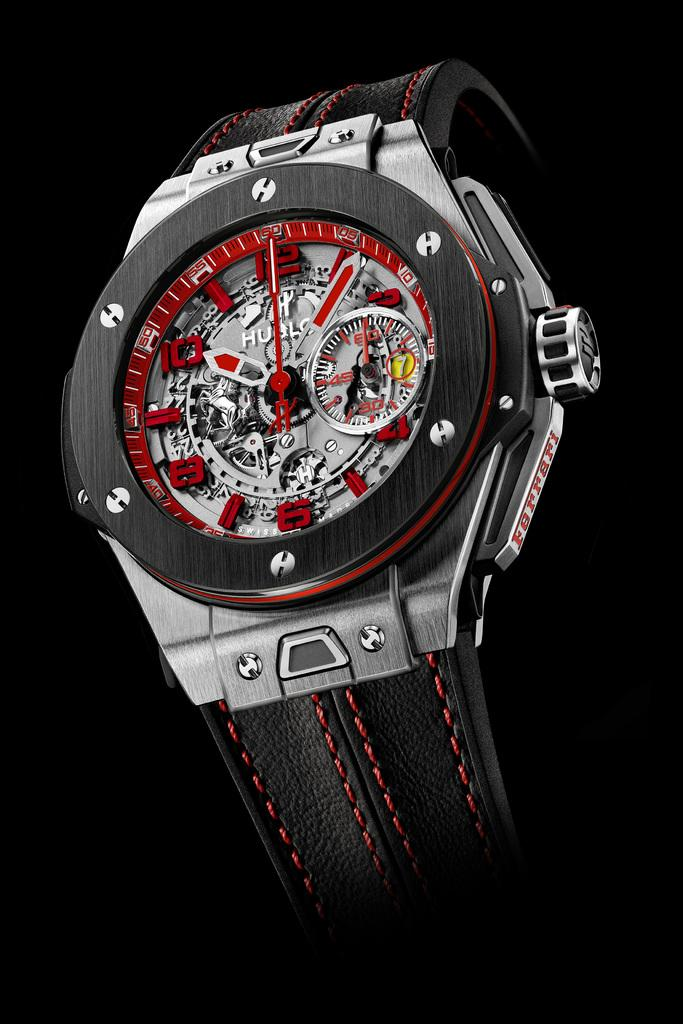<image>
Give a short and clear explanation of the subsequent image. A silver watch has the brand name Ferrari on the right side. 